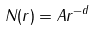Convert formula to latex. <formula><loc_0><loc_0><loc_500><loc_500>N ( r ) = A r ^ { - d }</formula> 